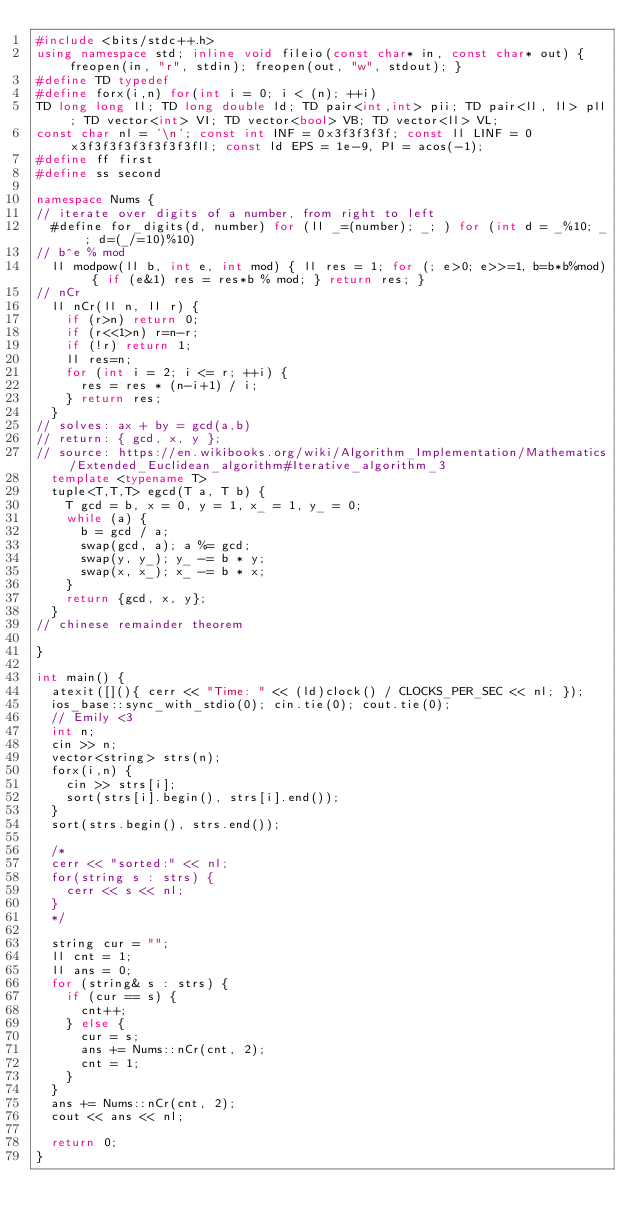Convert code to text. <code><loc_0><loc_0><loc_500><loc_500><_C++_>#include <bits/stdc++.h>
using namespace std; inline void fileio(const char* in, const char* out) { freopen(in, "r", stdin); freopen(out, "w", stdout); } 
#define TD typedef
#define forx(i,n) for(int i = 0; i < (n); ++i)
TD long long ll; TD long double ld; TD pair<int,int> pii; TD pair<ll, ll> pll; TD vector<int> VI; TD vector<bool> VB; TD vector<ll> VL;
const char nl = '\n'; const int INF = 0x3f3f3f3f; const ll LINF = 0x3f3f3f3f3f3f3f3fll; const ld EPS = 1e-9, PI = acos(-1);
#define ff first
#define ss second

namespace Nums {
// iterate over digits of a number, from right to left
  #define for_digits(d, number) for (ll _=(number); _; ) for (int d = _%10; _; d=(_/=10)%10)
// b^e % mod
  ll modpow(ll b, int e, int mod) { ll res = 1; for (; e>0; e>>=1, b=b*b%mod) { if (e&1) res = res*b % mod; } return res; }
// nCr
  ll nCr(ll n, ll r) {
    if (r>n) return 0;
    if (r<<1>n) r=n-r;
    if (!r) return 1;
    ll res=n;
    for (int i = 2; i <= r; ++i) {
      res = res * (n-i+1) / i;
    } return res;
  }
// solves: ax + by = gcd(a,b)
// return: { gcd, x, y };
// source: https://en.wikibooks.org/wiki/Algorithm_Implementation/Mathematics/Extended_Euclidean_algorithm#Iterative_algorithm_3
  template <typename T>
  tuple<T,T,T> egcd(T a, T b) {
    T gcd = b, x = 0, y = 1, x_ = 1, y_ = 0;
    while (a) {
      b = gcd / a;
      swap(gcd, a); a %= gcd;
      swap(y, y_); y_ -= b * y;
      swap(x, x_); x_ -= b * x;
    }
    return {gcd, x, y};
  }
// chinese remainder theorem
  
}

int main() {
  atexit([](){ cerr << "Time: " << (ld)clock() / CLOCKS_PER_SEC << nl; });
  ios_base::sync_with_stdio(0); cin.tie(0); cout.tie(0);
  // Emily <3
  int n;
  cin >> n;
  vector<string> strs(n);
  forx(i,n) {
    cin >> strs[i];
    sort(strs[i].begin(), strs[i].end());
  }
  sort(strs.begin(), strs.end());
  
  /*
  cerr << "sorted:" << nl;
  for(string s : strs) {
    cerr << s << nl;
  }
  */

  string cur = "";
  ll cnt = 1;
  ll ans = 0;
  for (string& s : strs) {
    if (cur == s) {
      cnt++;
    } else {
      cur = s;
      ans += Nums::nCr(cnt, 2);
      cnt = 1;
    }
  }
  ans += Nums::nCr(cnt, 2);
  cout << ans << nl;
  
  return 0;
}

</code> 